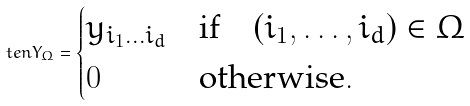<formula> <loc_0><loc_0><loc_500><loc_500>\ t e n { Y } _ { \Omega } = \begin{cases} y _ { i _ { 1 } \dots i _ { d } } & \text {if} \quad ( i _ { 1 } , \dots , i _ { d } ) \in \Omega \\ 0 & \text {otherwise} . \end{cases}</formula> 